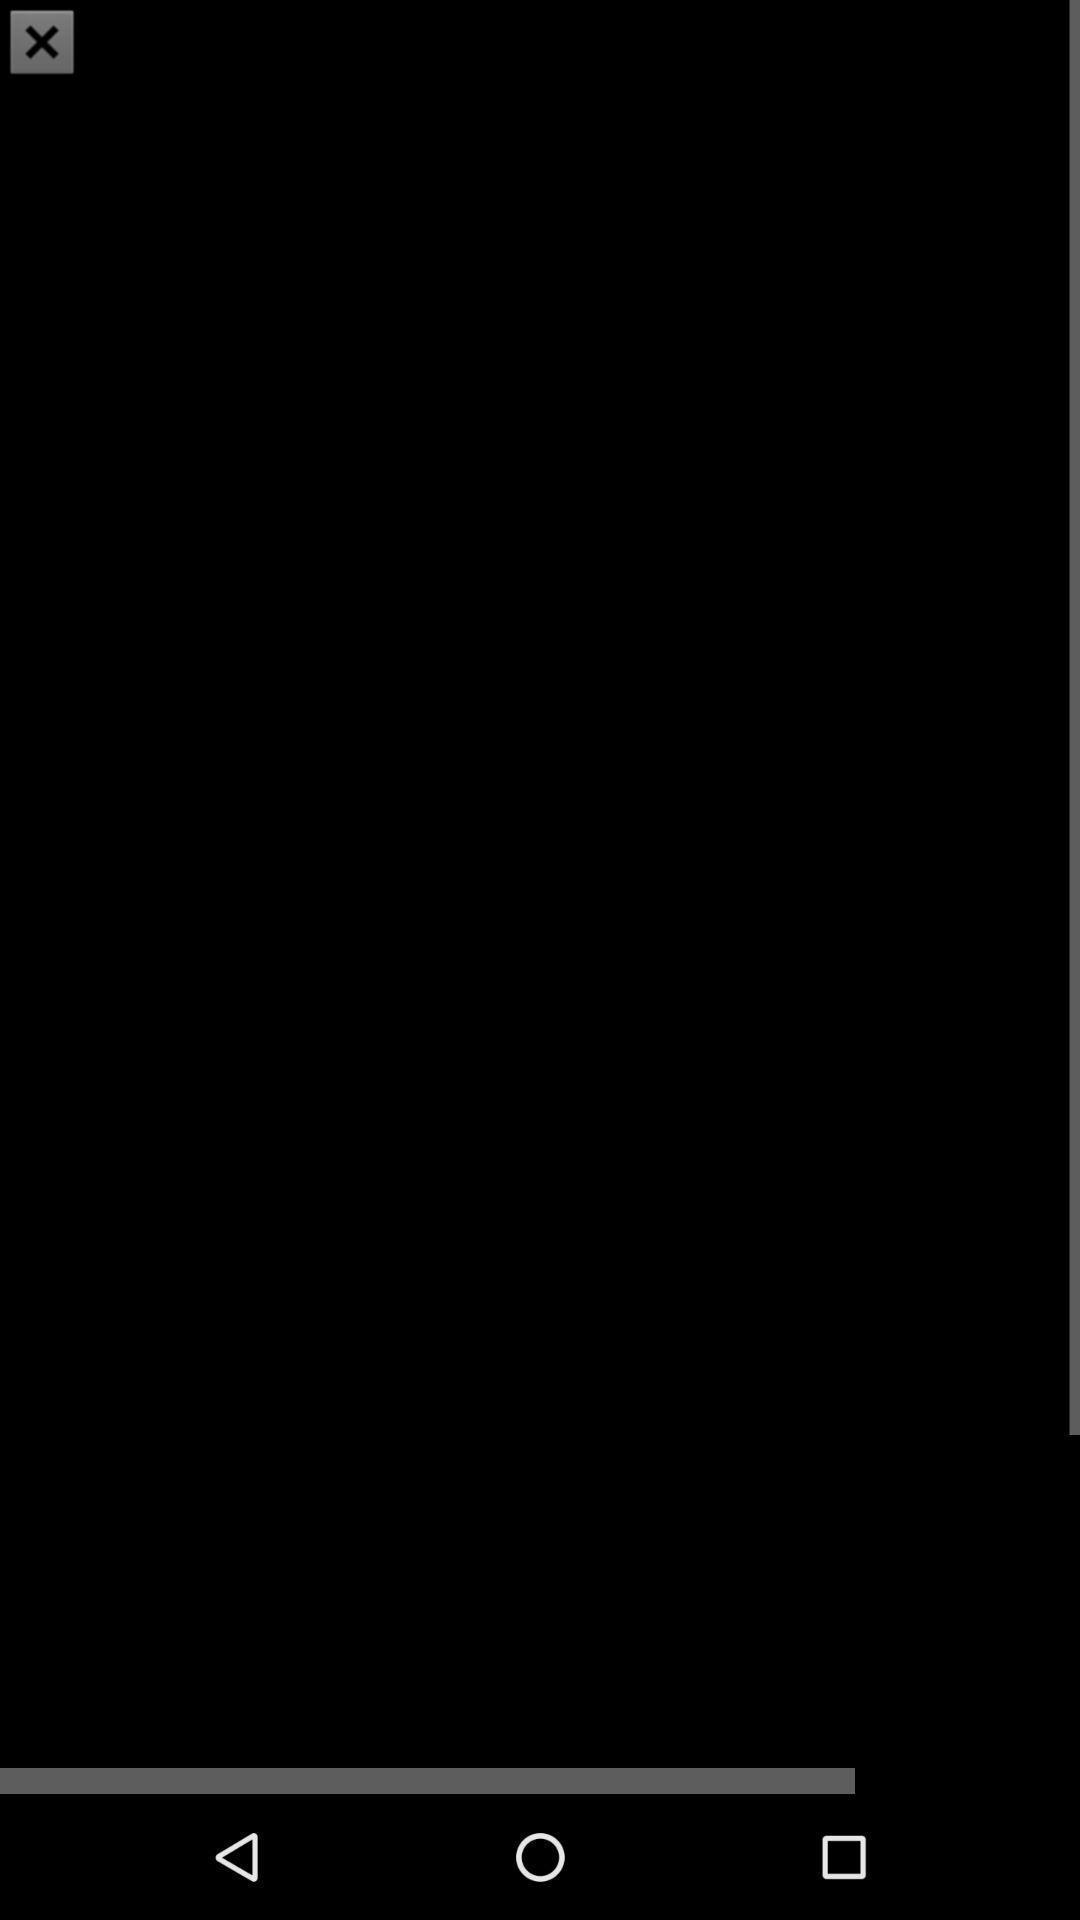Provide a description of this screenshot. Screen displaying a blank page. 